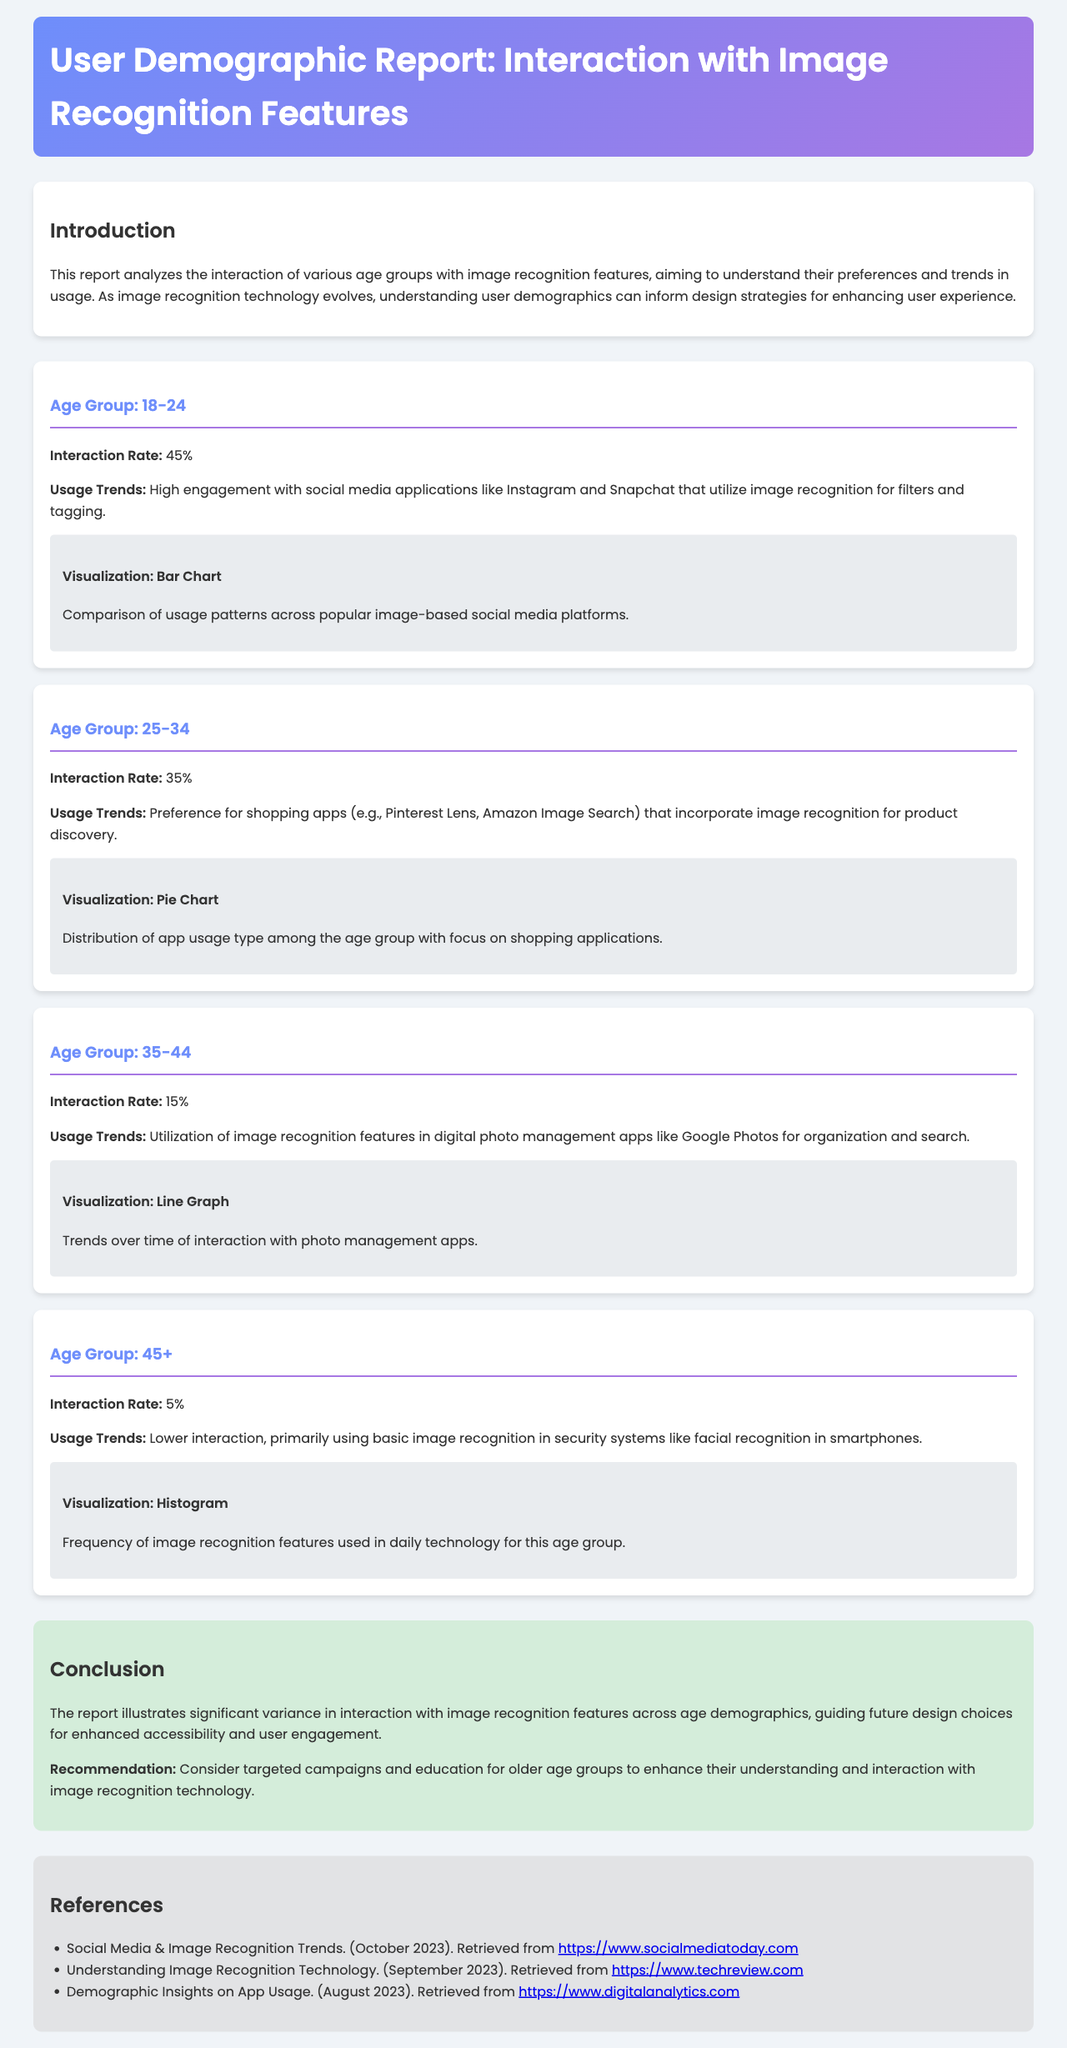What is the interaction rate for the age group 18-24? The interaction rate for the age group 18-24 is explicitly stated in the document as 45%.
Answer: 45% How many visualizations are presented for the age group 25-34? The document mentions one visualization for the age group 25-34 which is a pie chart.
Answer: One What usage trend is associated with the age group 35-44? The usage trend for the age group 35-44 involves utilization of image recognition features in digital photo management apps.
Answer: Digital photo management apps What is the interaction rate for the age group 45+? The interaction rate for the age group 45+ is noted in the document as 5%.
Answer: 5% What is the main recommendation given in the conclusion? The recommendation in the conclusion emphasizes targeted campaigns and education for older age groups to enhance their understanding of image recognition technology.
Answer: Targeted campaigns and education Which visualization type is used for the age group 18-24? The document specifies that a bar chart is used for the age group 18-24.
Answer: Bar Chart How does the interaction rate for the age group 25-34 compare to that of 18-24? The interaction rate for 25-34 is 35%, which is lower than 18-24's rate of 45%.
Answer: Lower What color theme is used for the report header? The header uses a linear gradient with colors #6e8efb and #a777e3.
Answer: Linear Gradient What type of applications do users in the age group 45+ primarily engage with? Users in the age group 45+ primarily engage with basic image recognition in security systems.
Answer: Security systems 